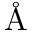Convert formula to latex. <formula><loc_0><loc_0><loc_500><loc_500>\AA</formula> 